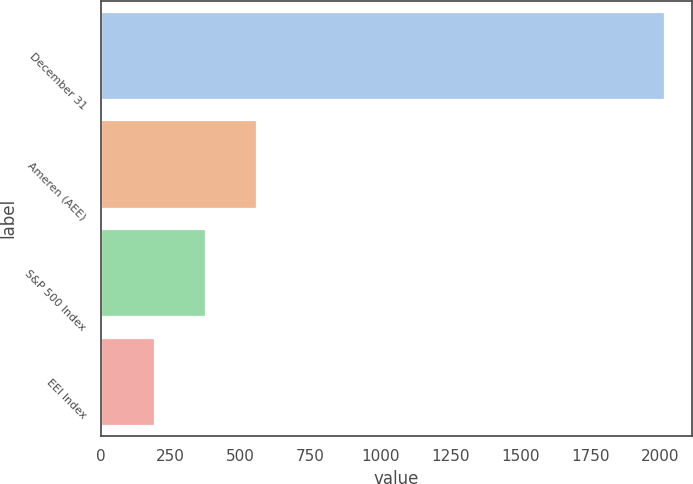<chart> <loc_0><loc_0><loc_500><loc_500><bar_chart><fcel>December 31<fcel>Ameren (AEE)<fcel>S&P 500 Index<fcel>EEI Index<nl><fcel>2014<fcel>555.62<fcel>373.32<fcel>191.02<nl></chart> 